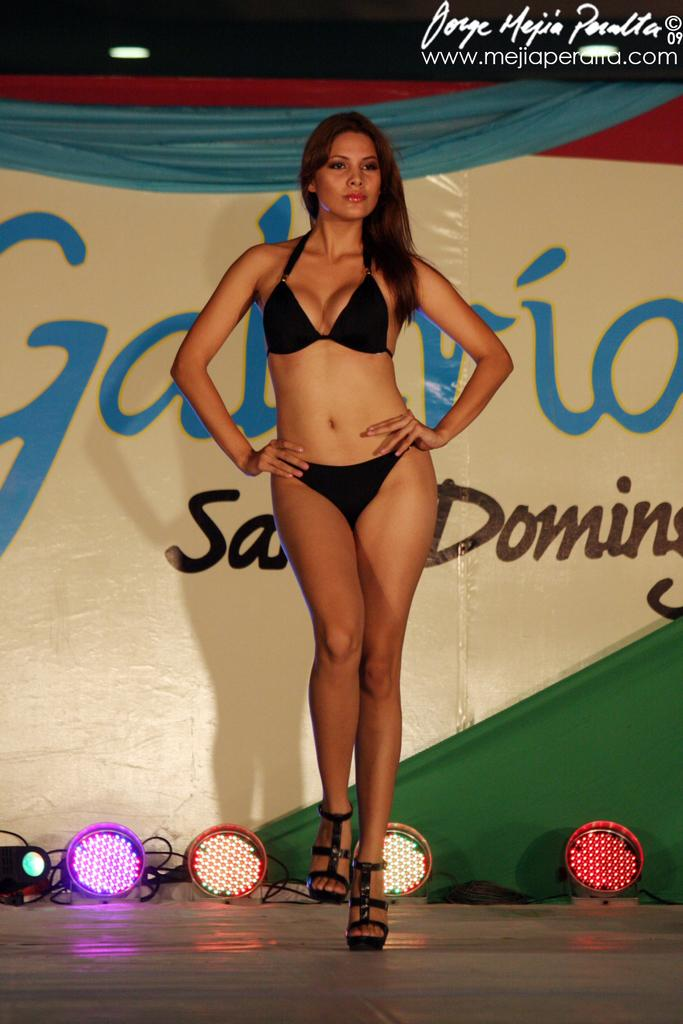What is the girl doing in the image? The girl is standing on the stage in the image. What can be seen behind the girl on the stage? There is a banner behind the girl in the image. What type of illumination is present in the image? There are lights visible in the image. Is there any text or logo present in the image? Yes, there is a watermark at the top of the image. Can you hear the horn and drum being played by the tiger in the image? There is no tiger, horn, or drum present in the image. 